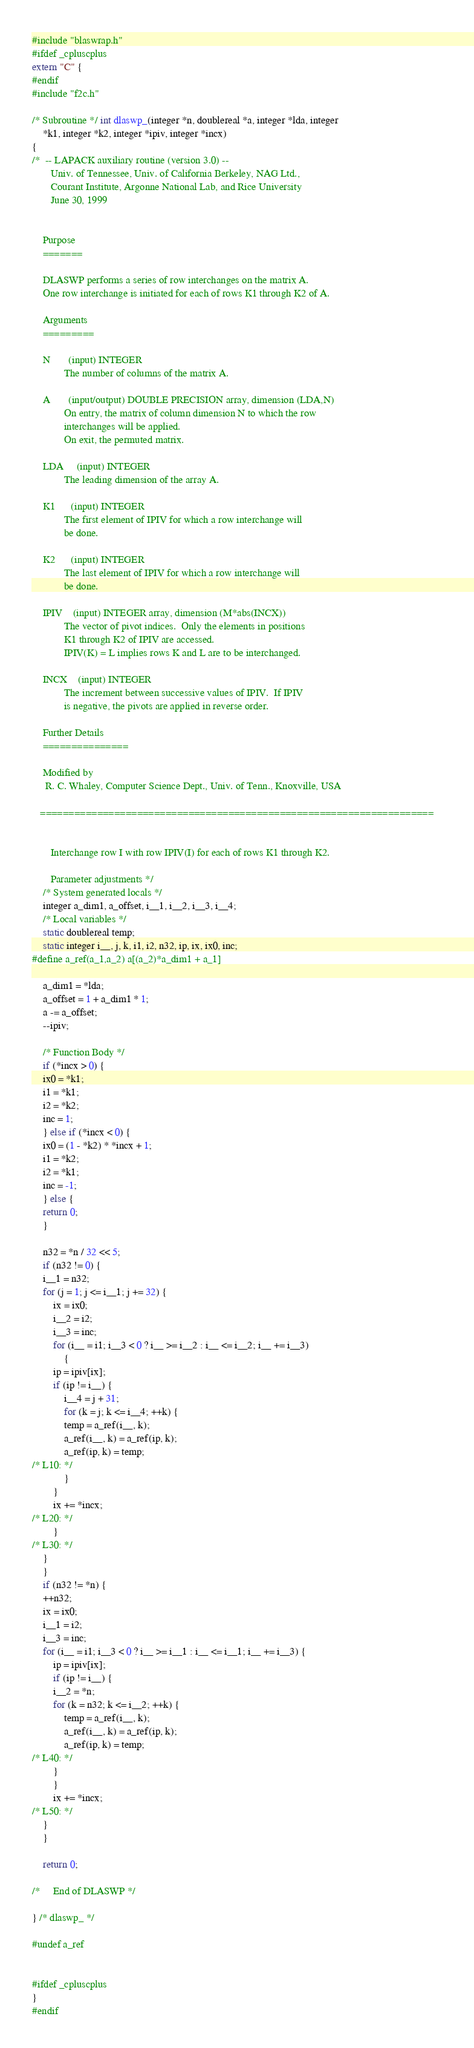<code> <loc_0><loc_0><loc_500><loc_500><_C_>#include "blaswrap.h"
#ifdef _cpluscplus
extern "C" {
#endif
#include "f2c.h"

/* Subroutine */ int dlaswp_(integer *n, doublereal *a, integer *lda, integer 
	*k1, integer *k2, integer *ipiv, integer *incx)
{
/*  -- LAPACK auxiliary routine (version 3.0) --   
       Univ. of Tennessee, Univ. of California Berkeley, NAG Ltd.,   
       Courant Institute, Argonne National Lab, and Rice University   
       June 30, 1999   


    Purpose   
    =======   

    DLASWP performs a series of row interchanges on the matrix A.   
    One row interchange is initiated for each of rows K1 through K2 of A.   

    Arguments   
    =========   

    N       (input) INTEGER   
            The number of columns of the matrix A.   

    A       (input/output) DOUBLE PRECISION array, dimension (LDA,N)   
            On entry, the matrix of column dimension N to which the row   
            interchanges will be applied.   
            On exit, the permuted matrix.   

    LDA     (input) INTEGER   
            The leading dimension of the array A.   

    K1      (input) INTEGER   
            The first element of IPIV for which a row interchange will   
            be done.   

    K2      (input) INTEGER   
            The last element of IPIV for which a row interchange will   
            be done.   

    IPIV    (input) INTEGER array, dimension (M*abs(INCX))   
            The vector of pivot indices.  Only the elements in positions   
            K1 through K2 of IPIV are accessed.   
            IPIV(K) = L implies rows K and L are to be interchanged.   

    INCX    (input) INTEGER   
            The increment between successive values of IPIV.  If IPIV   
            is negative, the pivots are applied in reverse order.   

    Further Details   
    ===============   

    Modified by   
     R. C. Whaley, Computer Science Dept., Univ. of Tenn., Knoxville, USA   

   =====================================================================   


       Interchange row I with row IPIV(I) for each of rows K1 through K2.   

       Parameter adjustments */
    /* System generated locals */
    integer a_dim1, a_offset, i__1, i__2, i__3, i__4;
    /* Local variables */
    static doublereal temp;
    static integer i__, j, k, i1, i2, n32, ip, ix, ix0, inc;
#define a_ref(a_1,a_2) a[(a_2)*a_dim1 + a_1]

    a_dim1 = *lda;
    a_offset = 1 + a_dim1 * 1;
    a -= a_offset;
    --ipiv;

    /* Function Body */
    if (*incx > 0) {
	ix0 = *k1;
	i1 = *k1;
	i2 = *k2;
	inc = 1;
    } else if (*incx < 0) {
	ix0 = (1 - *k2) * *incx + 1;
	i1 = *k2;
	i2 = *k1;
	inc = -1;
    } else {
	return 0;
    }

    n32 = *n / 32 << 5;
    if (n32 != 0) {
	i__1 = n32;
	for (j = 1; j <= i__1; j += 32) {
	    ix = ix0;
	    i__2 = i2;
	    i__3 = inc;
	    for (i__ = i1; i__3 < 0 ? i__ >= i__2 : i__ <= i__2; i__ += i__3) 
		    {
		ip = ipiv[ix];
		if (ip != i__) {
		    i__4 = j + 31;
		    for (k = j; k <= i__4; ++k) {
			temp = a_ref(i__, k);
			a_ref(i__, k) = a_ref(ip, k);
			a_ref(ip, k) = temp;
/* L10: */
		    }
		}
		ix += *incx;
/* L20: */
	    }
/* L30: */
	}
    }
    if (n32 != *n) {
	++n32;
	ix = ix0;
	i__1 = i2;
	i__3 = inc;
	for (i__ = i1; i__3 < 0 ? i__ >= i__1 : i__ <= i__1; i__ += i__3) {
	    ip = ipiv[ix];
	    if (ip != i__) {
		i__2 = *n;
		for (k = n32; k <= i__2; ++k) {
		    temp = a_ref(i__, k);
		    a_ref(i__, k) = a_ref(ip, k);
		    a_ref(ip, k) = temp;
/* L40: */
		}
	    }
	    ix += *incx;
/* L50: */
	}
    }

    return 0;

/*     End of DLASWP */

} /* dlaswp_ */

#undef a_ref


#ifdef _cpluscplus
}
#endif
</code> 